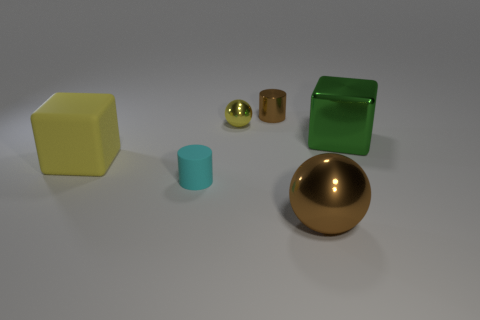Add 2 big brown metal spheres. How many objects exist? 8 Subtract all blocks. How many objects are left? 4 Add 3 small yellow metallic things. How many small yellow metallic things exist? 4 Subtract 0 red blocks. How many objects are left? 6 Subtract all big yellow things. Subtract all small cyan cylinders. How many objects are left? 4 Add 4 brown objects. How many brown objects are left? 6 